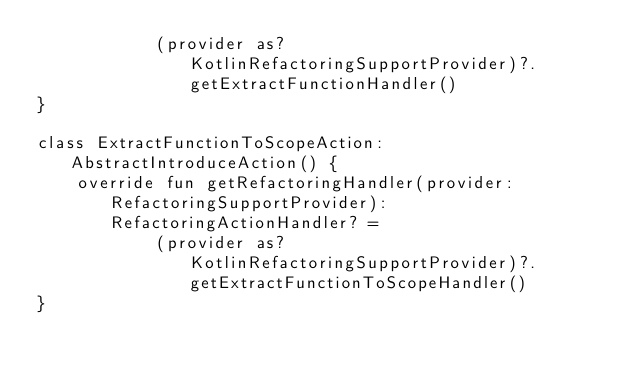Convert code to text. <code><loc_0><loc_0><loc_500><loc_500><_Kotlin_>            (provider as? KotlinRefactoringSupportProvider)?.getExtractFunctionHandler()
}

class ExtractFunctionToScopeAction: AbstractIntroduceAction() {
    override fun getRefactoringHandler(provider: RefactoringSupportProvider): RefactoringActionHandler? =
            (provider as? KotlinRefactoringSupportProvider)?.getExtractFunctionToScopeHandler()
}
</code> 